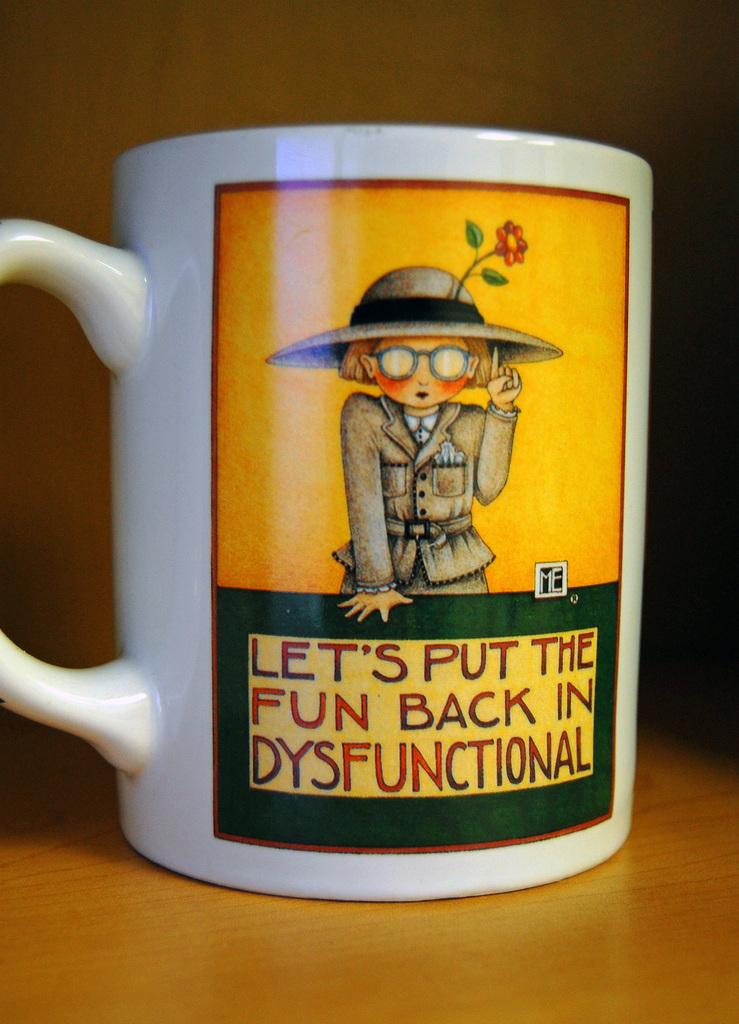<image>
Summarize the visual content of the image. A coffee cup that says let's put the fun back in dysfunctional. 